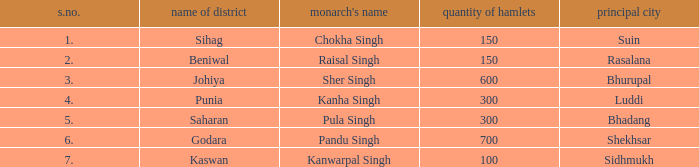What capital has an S.Number under 7, and a Name of janapada of Punia? Luddi. 